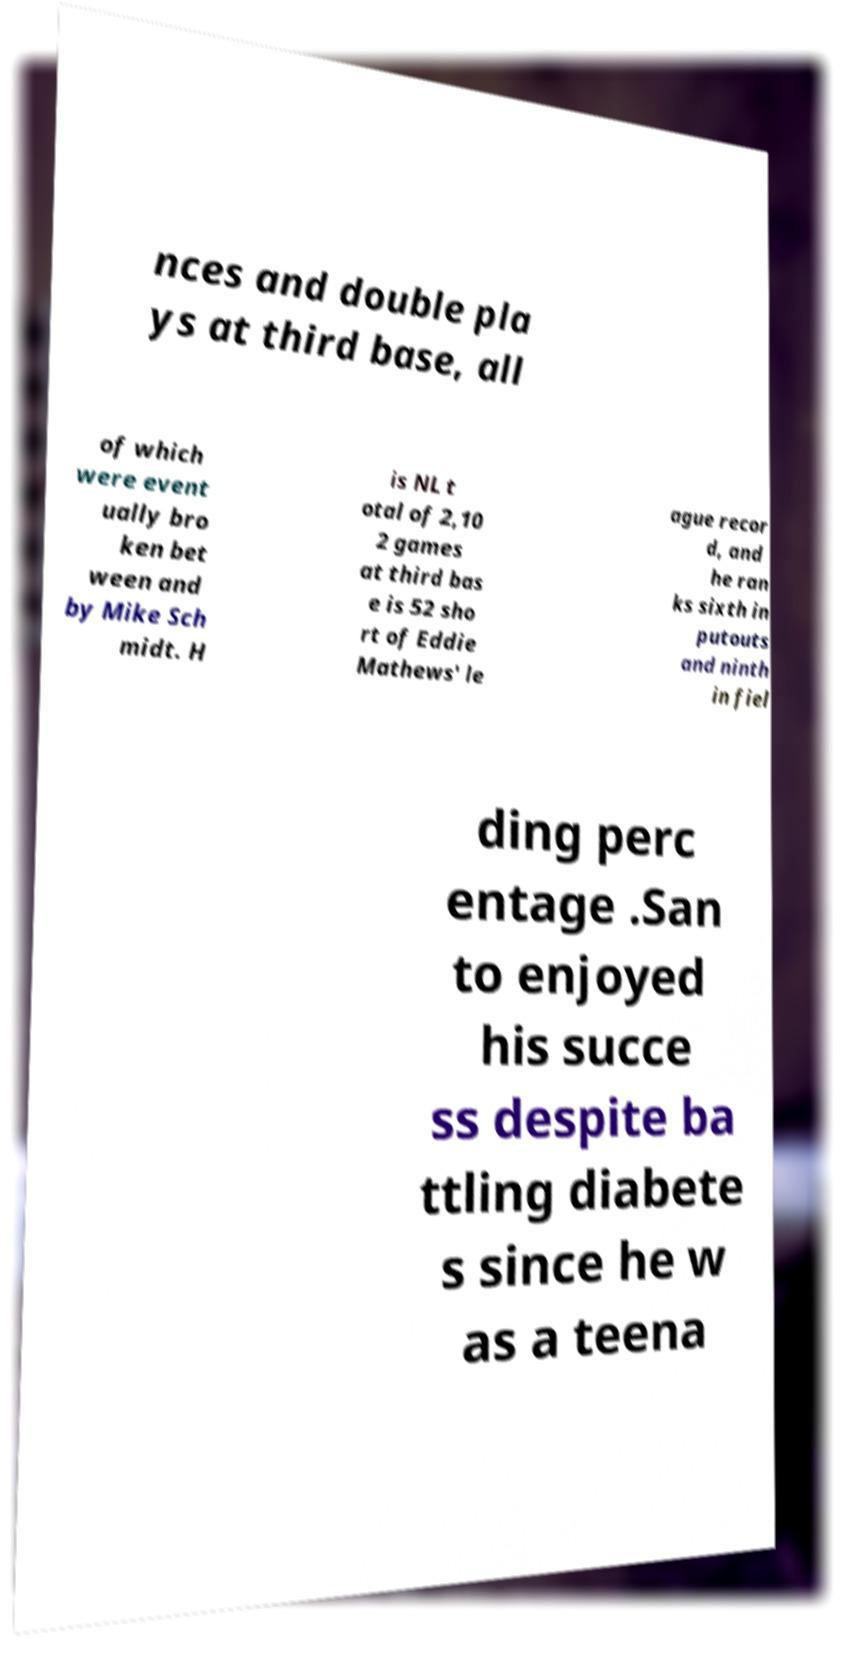For documentation purposes, I need the text within this image transcribed. Could you provide that? nces and double pla ys at third base, all of which were event ually bro ken bet ween and by Mike Sch midt. H is NL t otal of 2,10 2 games at third bas e is 52 sho rt of Eddie Mathews' le ague recor d, and he ran ks sixth in putouts and ninth in fiel ding perc entage .San to enjoyed his succe ss despite ba ttling diabete s since he w as a teena 